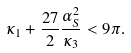<formula> <loc_0><loc_0><loc_500><loc_500>\kappa _ { 1 } + \frac { 2 7 } { 2 } \frac { \alpha _ { S } ^ { 2 } } { \kappa _ { 3 } } < 9 \pi .</formula> 